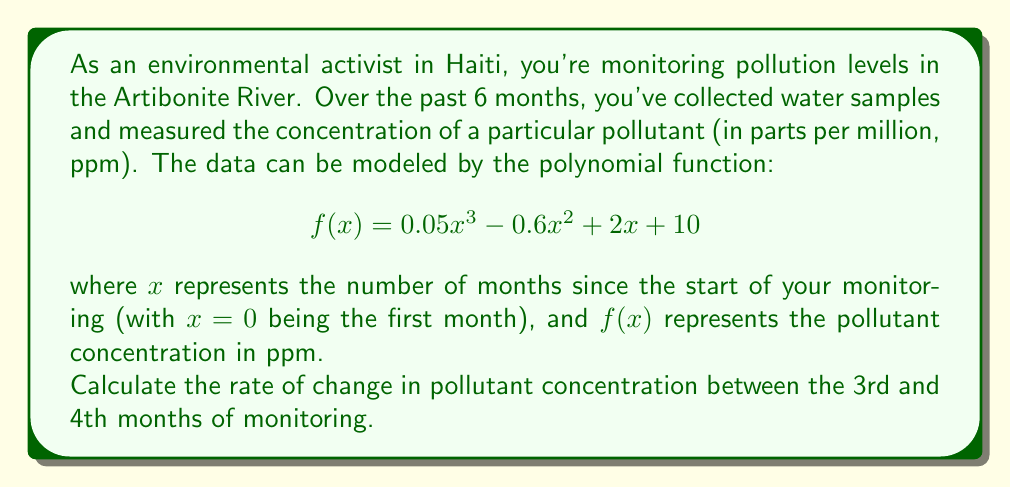Show me your answer to this math problem. To solve this problem, we need to follow these steps:

1) The rate of change between two points is given by the average rate of change formula:

   $$\text{Rate of change} = \frac{f(b) - f(a)}{b - a}$$

   where $a$ and $b$ are the input values (in this case, months).

2) We need to calculate $f(3)$ and $f(4)$:

   For $x = 3$:
   $$f(3) = 0.05(3)^3 - 0.6(3)^2 + 2(3) + 10$$
   $$= 0.05(27) - 0.6(9) + 6 + 10$$
   $$= 1.35 - 5.4 + 6 + 10 = 11.95$$

   For $x = 4$:
   $$f(4) = 0.05(4)^3 - 0.6(4)^2 + 2(4) + 10$$
   $$= 0.05(64) - 0.6(16) + 8 + 10$$
   $$= 3.2 - 9.6 + 8 + 10 = 11.6$$

3) Now we can apply the rate of change formula:

   $$\text{Rate of change} = \frac{f(4) - f(3)}{4 - 3} = \frac{11.6 - 11.95}{1} = -0.35$$

Therefore, the rate of change in pollutant concentration between the 3rd and 4th months is -0.35 ppm per month.
Answer: -0.35 ppm per month 